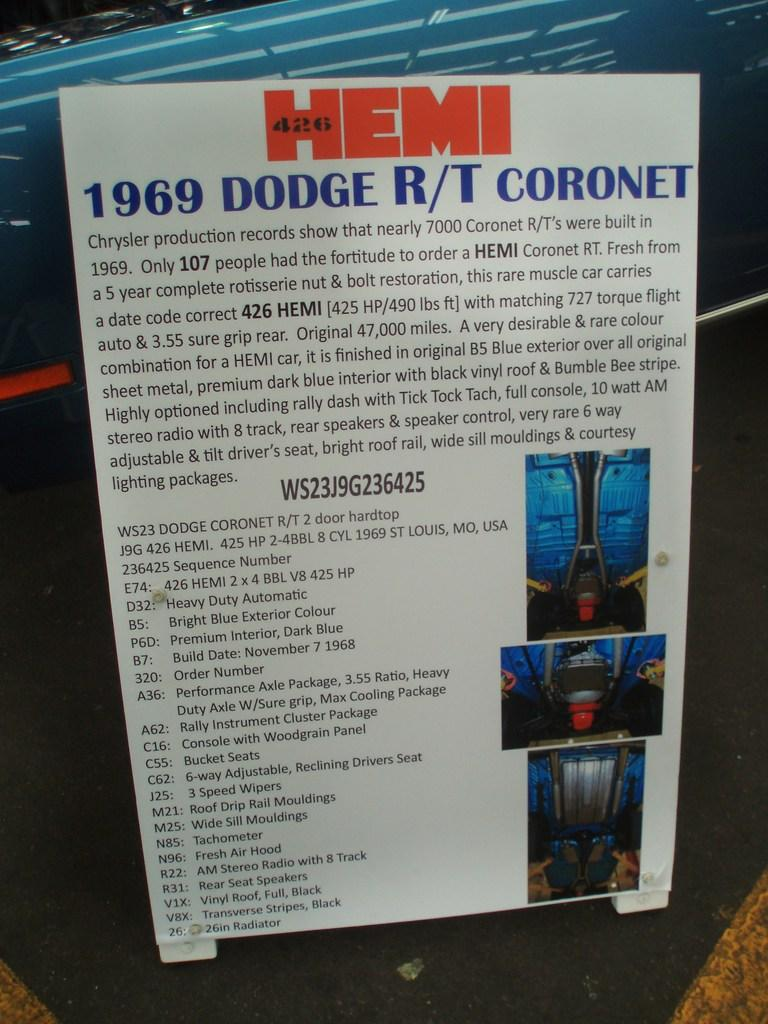<image>
Present a compact description of the photo's key features. Text describing a coronet from 1969 and magonified in part. 